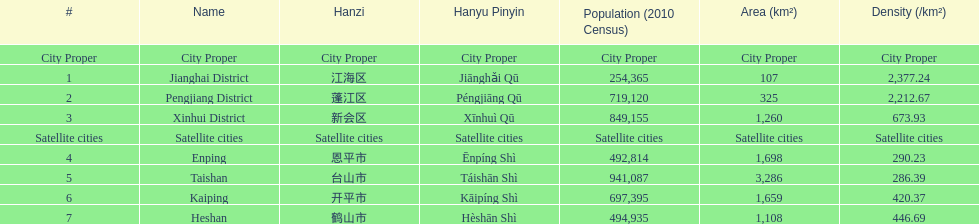What urban centers are located in jiangmen? Jianghai District, Pengjiang District, Xinhui District, Enping, Taishan, Kaiping, Heshan. From them, which ones qualify as a city proper? Jianghai District, Pengjiang District, Xinhui District. From those, which one covers the least area in square kilometers? Jianghai District. 